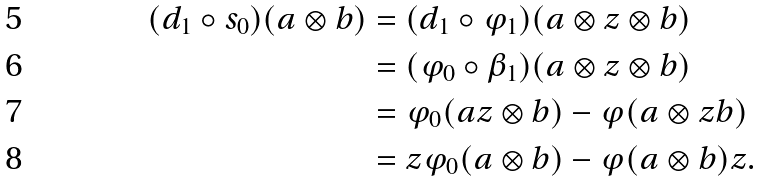<formula> <loc_0><loc_0><loc_500><loc_500>( d _ { 1 } \circ s _ { 0 } ) ( a \otimes b ) & = ( d _ { 1 } \circ \varphi _ { 1 } ) ( a \otimes z \otimes b ) \\ & = ( \varphi _ { 0 } \circ \beta _ { 1 } ) ( a \otimes z \otimes b ) \\ & = \varphi _ { 0 } ( a z \otimes b ) - \varphi ( a \otimes z b ) \\ & = z \varphi _ { 0 } ( a \otimes b ) - \varphi ( a \otimes b ) z .</formula> 